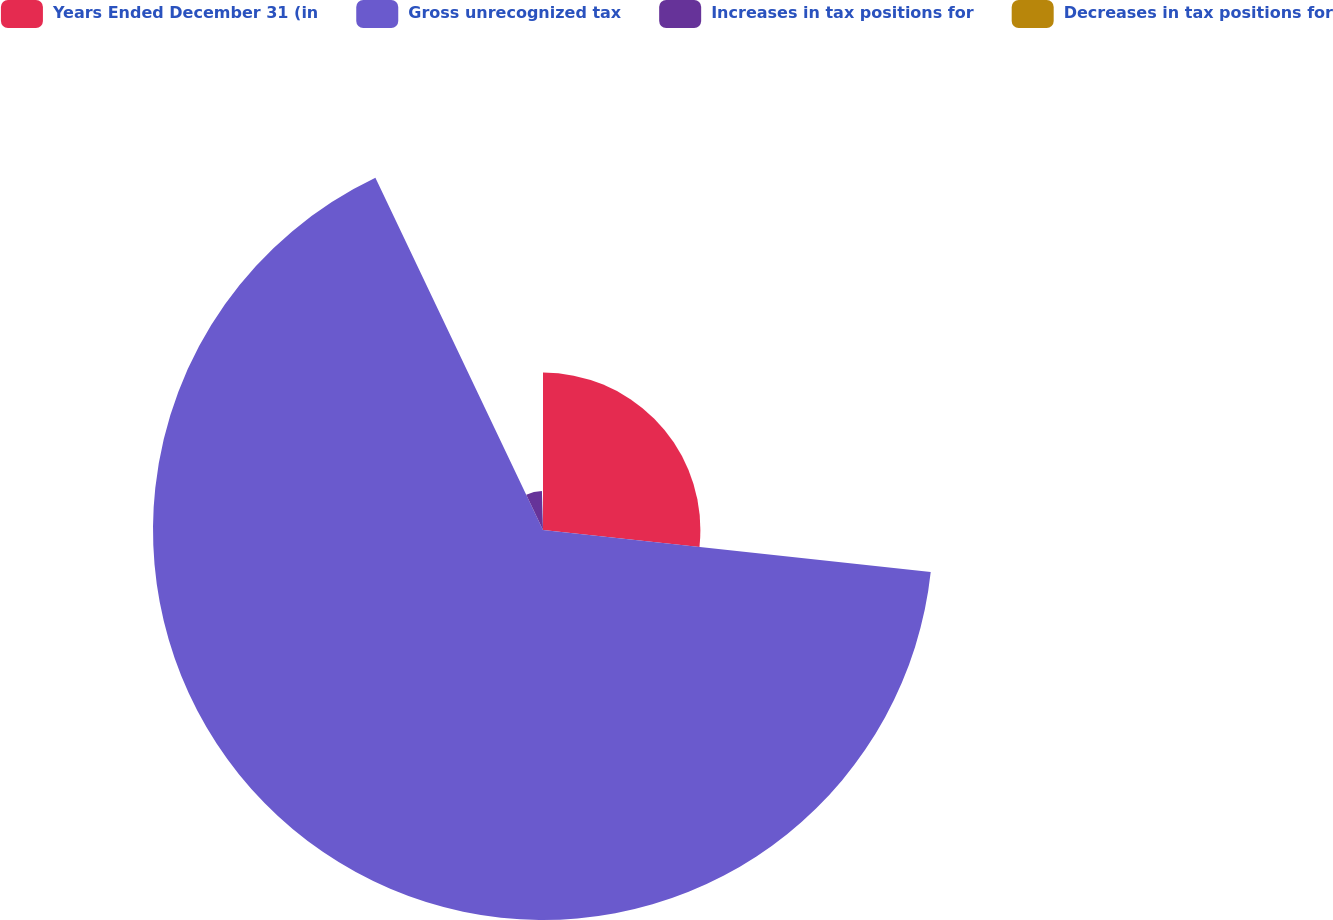Convert chart. <chart><loc_0><loc_0><loc_500><loc_500><pie_chart><fcel>Years Ended December 31 (in<fcel>Gross unrecognized tax<fcel>Increases in tax positions for<fcel>Decreases in tax positions for<nl><fcel>26.72%<fcel>66.21%<fcel>6.63%<fcel>0.44%<nl></chart> 